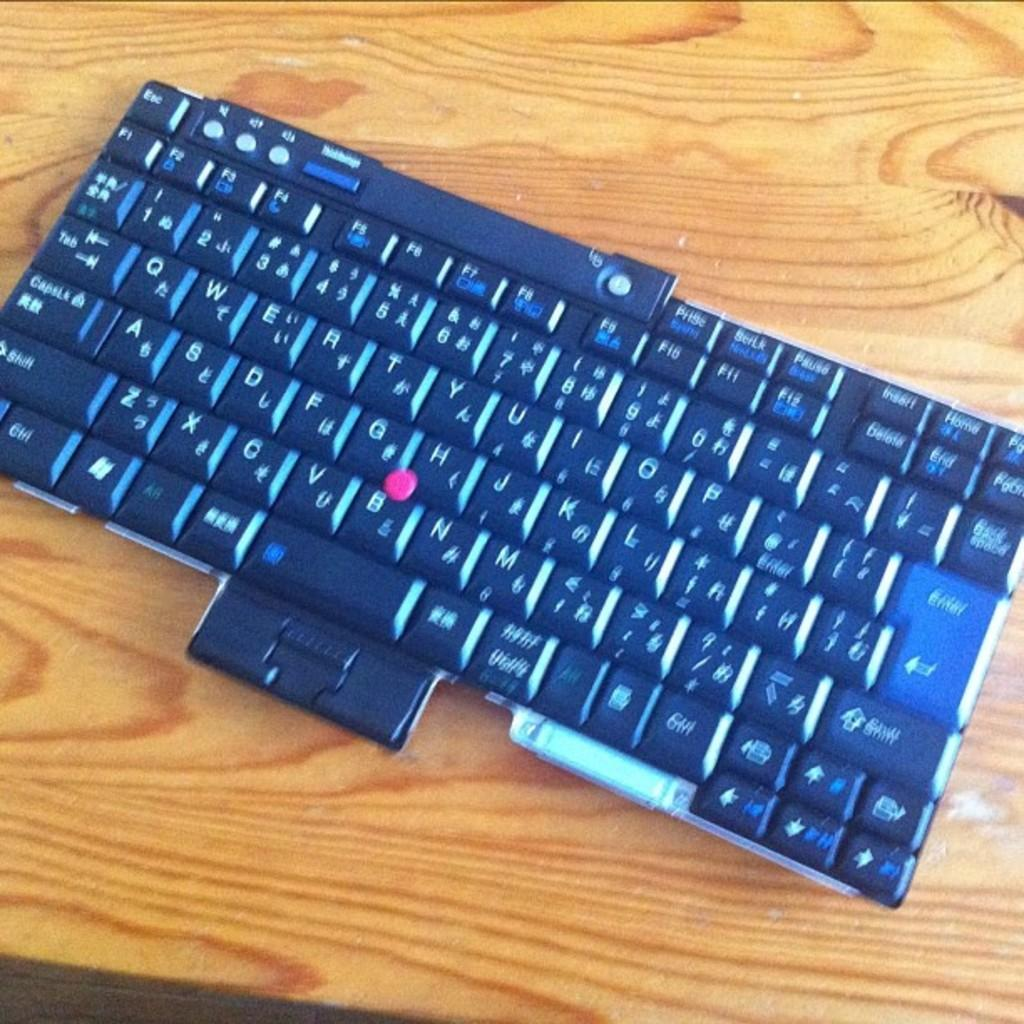<image>
Provide a brief description of the given image. A keyboard is sitting on a wooden desk and has a pink circle between the letters g and h. 